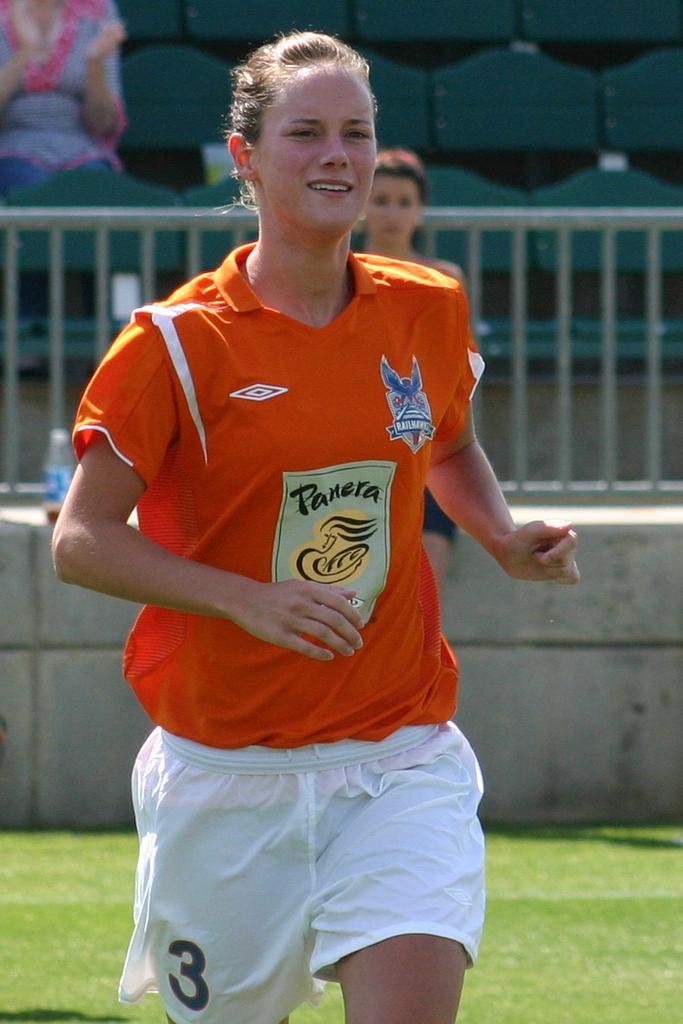<image>
Create a compact narrative representing the image presented. The female sports person has the number 3 on her shorts. 